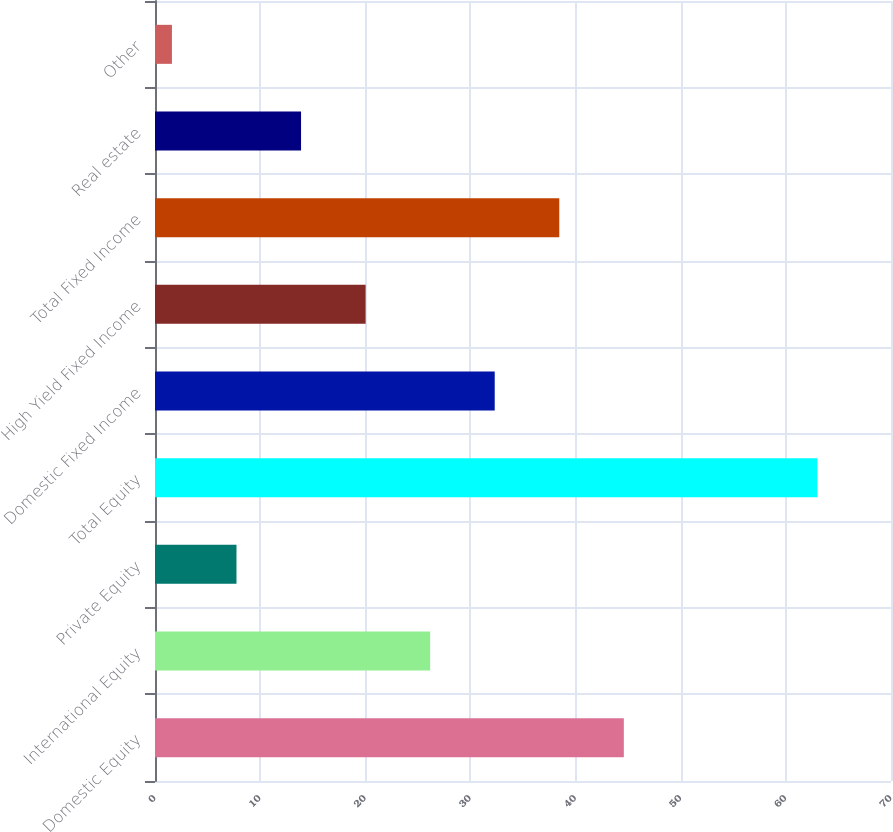Convert chart. <chart><loc_0><loc_0><loc_500><loc_500><bar_chart><fcel>Domestic Equity<fcel>International Equity<fcel>Private Equity<fcel>Total Equity<fcel>Domestic Fixed Income<fcel>High Yield Fixed Income<fcel>Total Fixed Income<fcel>Real estate<fcel>Other<nl><fcel>44.59<fcel>26.17<fcel>7.75<fcel>63<fcel>32.31<fcel>20.03<fcel>38.45<fcel>13.89<fcel>1.61<nl></chart> 